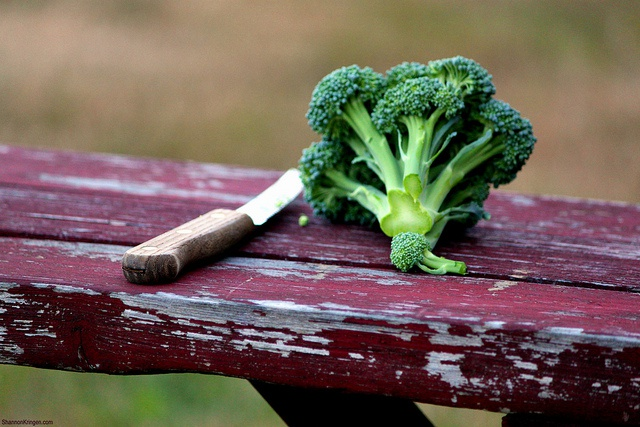Describe the objects in this image and their specific colors. I can see bench in gray, black, purple, and maroon tones, broccoli in gray, black, darkgreen, green, and lightgreen tones, and knife in gray, white, black, and darkgray tones in this image. 